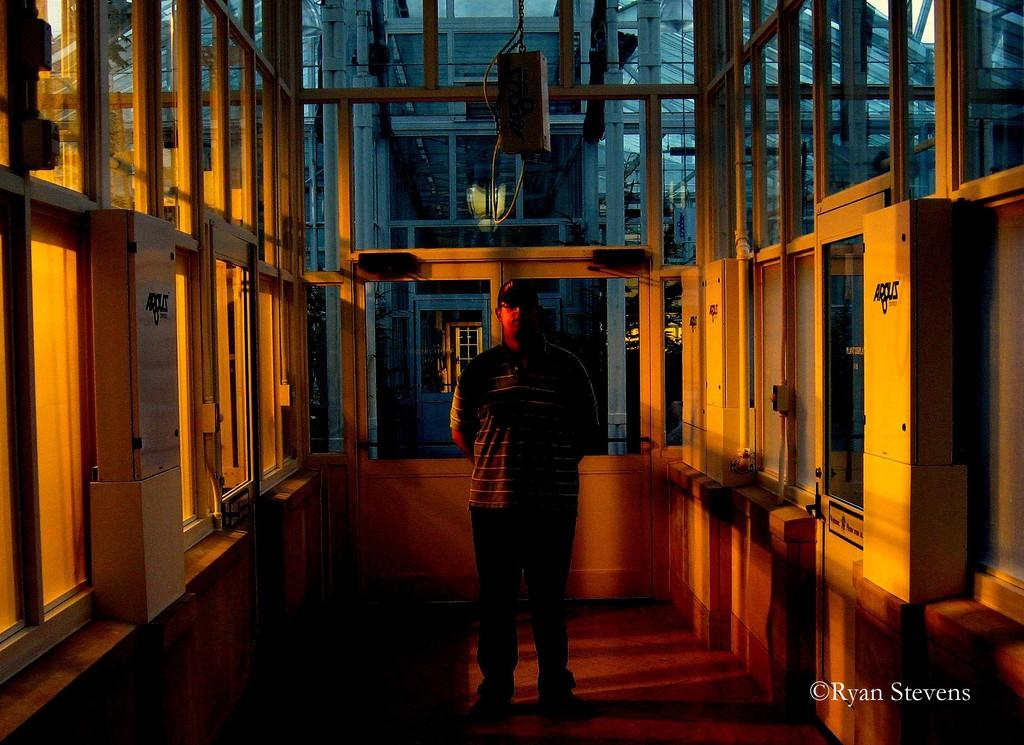What is the main subject in the middle of the room? There is a person standing in the middle of the room. What can be seen through the windows in the room? The presence of windows in the room suggests that there might be a view of the outdoors, but the specific view cannot be determined from the facts provided. What objects are present in the room? There are boxes and poles in the room. What type of illumination is present in the room? There is a light in the room. Is there any text visible in the image? Yes, there is text visible on the image. What type of produce can be seen growing in the garden outside the windows? There is no garden visible through the windows in the image, and therefore no produce can be seen growing. Is there a pear hanging from one of the poles in the room? There is no pear present in the image; only boxes and poles are visible. 